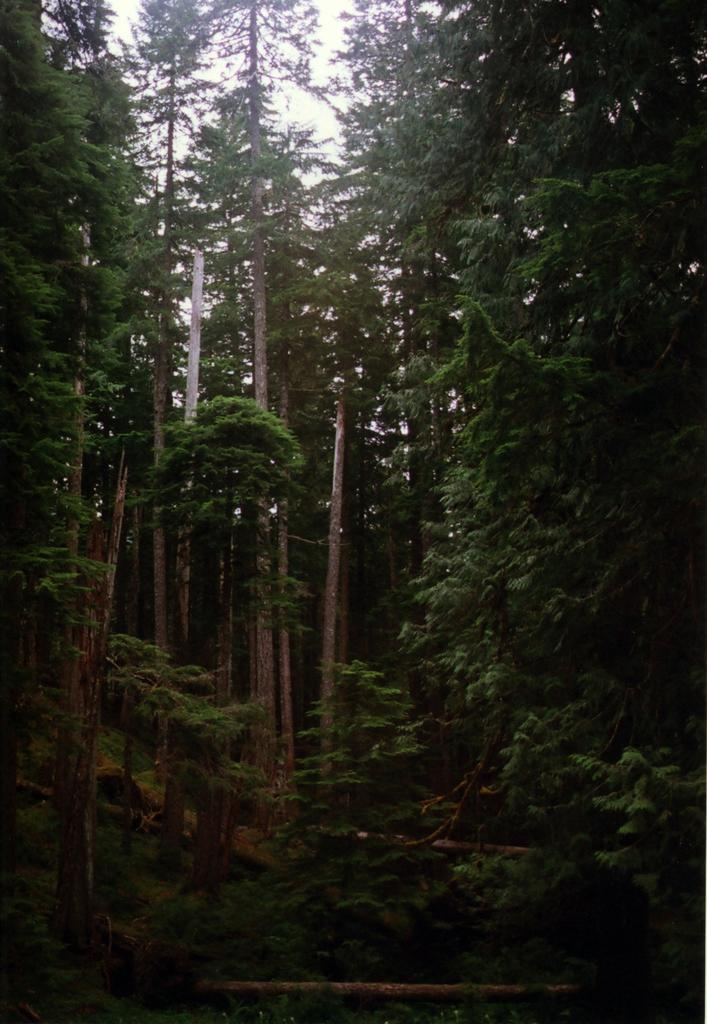What type of vegetation can be seen in the image? There are many trees in the image. What else is visible in the image besides the trees? The sky is visible in the image. What type of berry is hanging from the trees in the image? There is no berry present in the image; it only features trees and the sky. What type of current is flowing through the trees in the image? There is no current present in the image; it only features trees and the sky. 